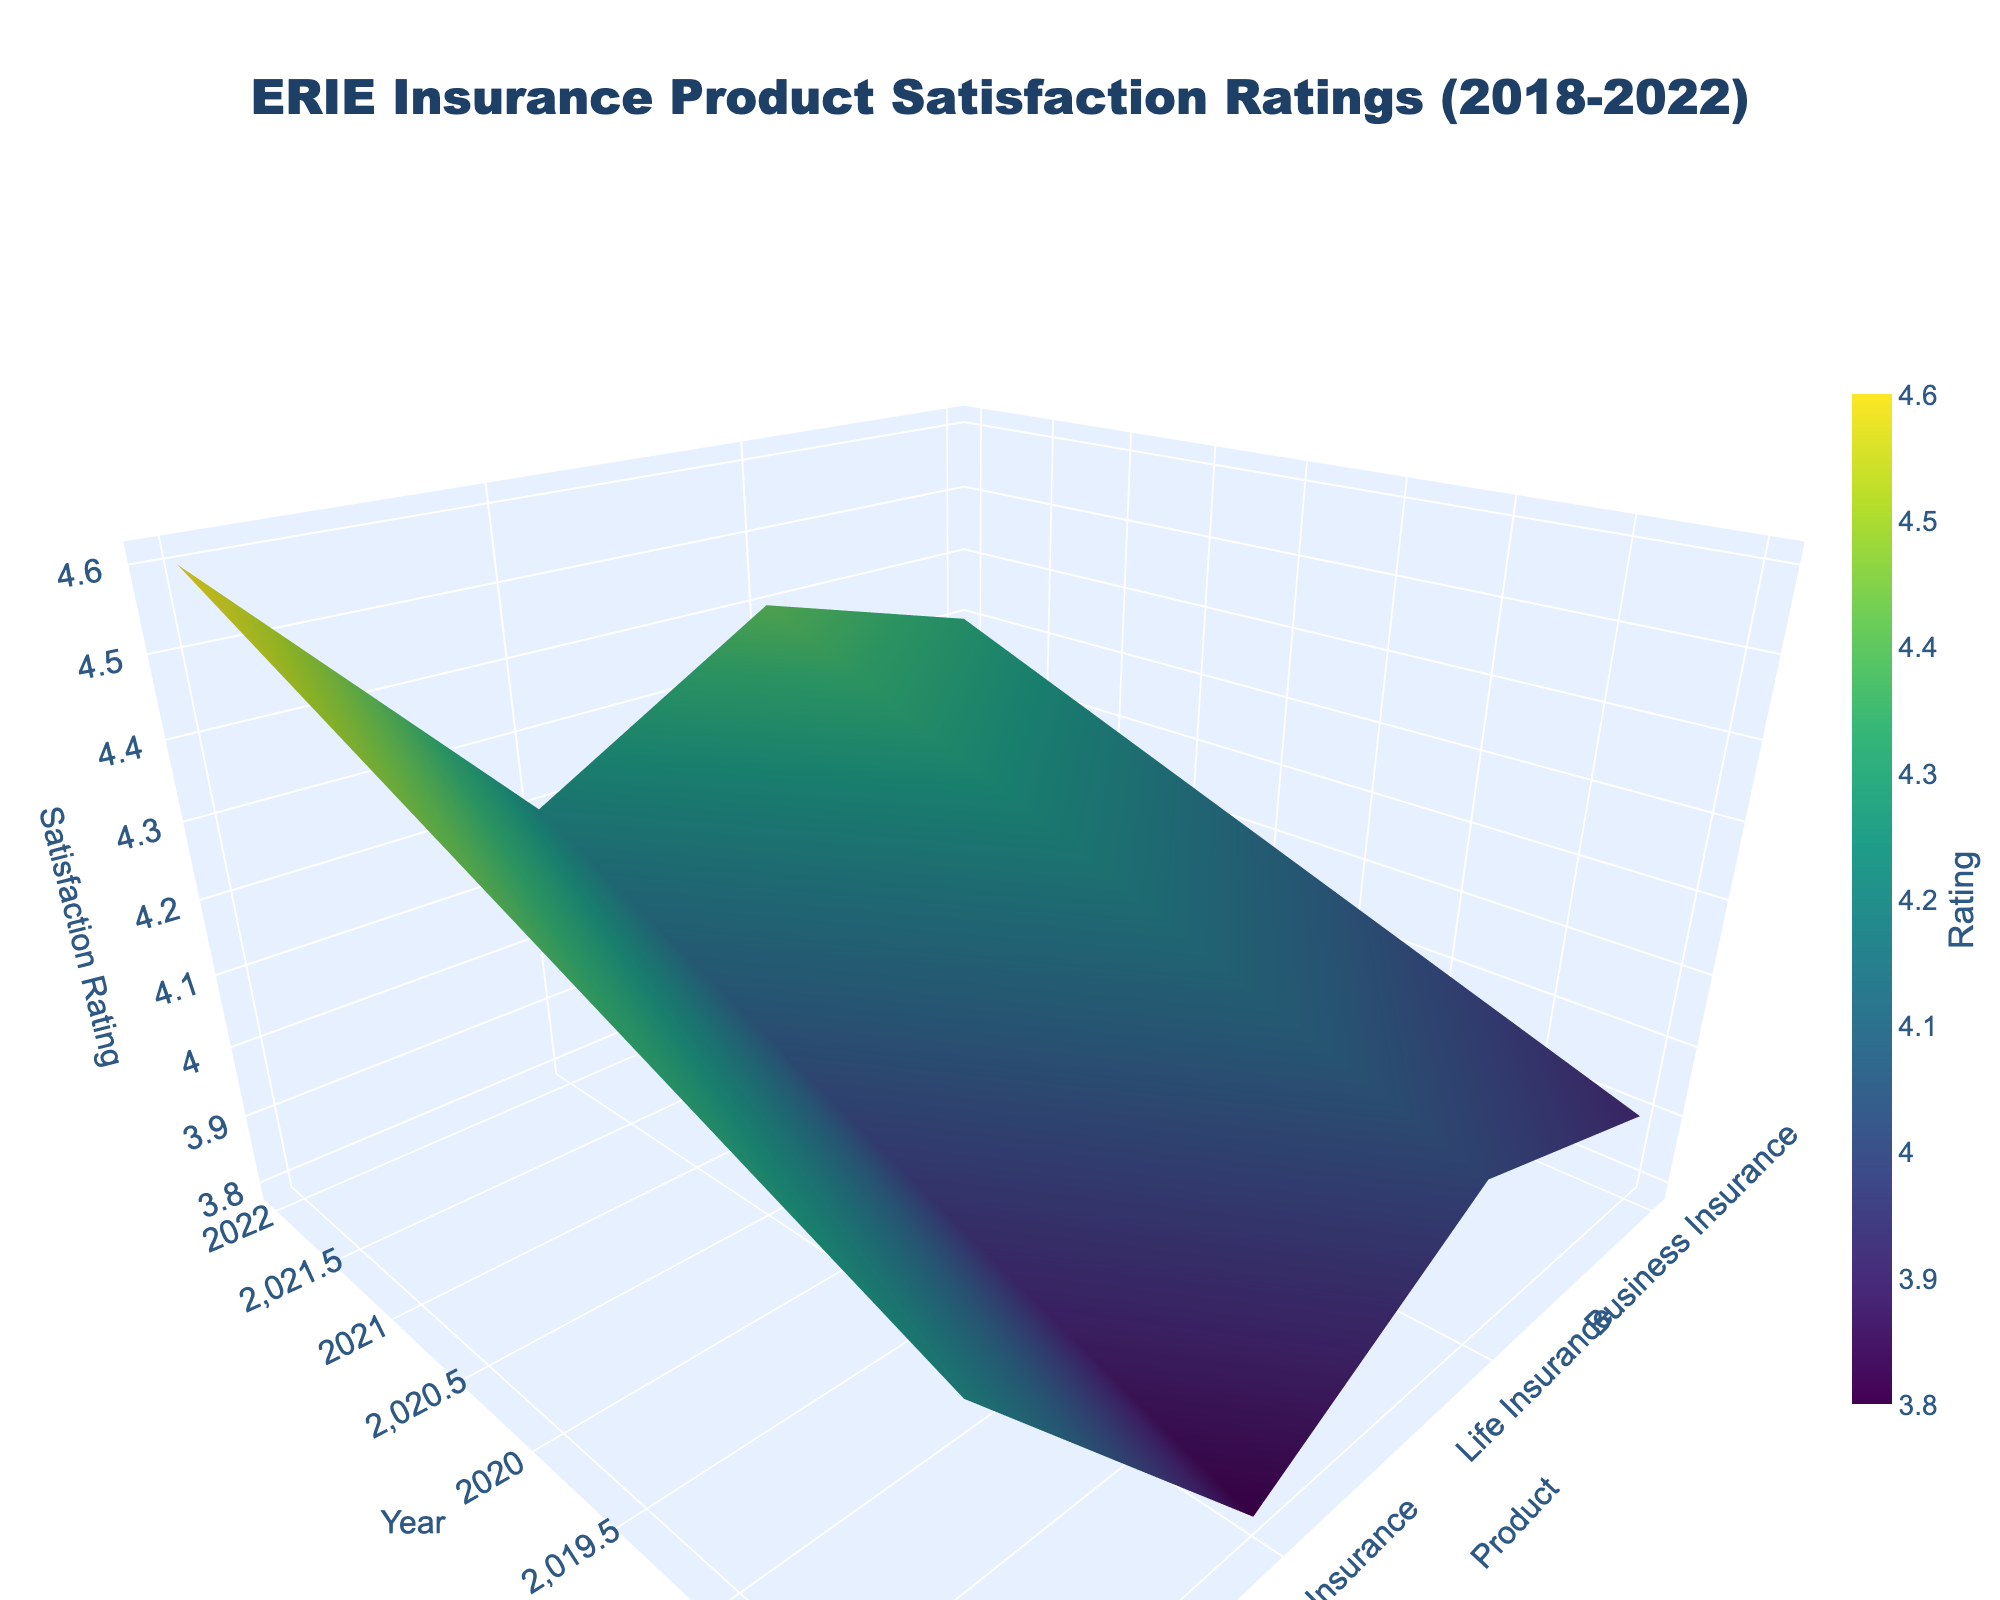What's the title of the plot? The title of the plot is displayed at the top and usually provides a succinct description of the data presented. In this case, it tells us about the content and the time range covered.
Answer: ERIE Insurance Product Satisfaction Ratings (2018-2022) Which product had the highest satisfaction rating in 2022? By examining the plot, we look at the section corresponding to 2022 on the year axis and find the highest point on the satisfaction rating axis among the different products.
Answer: Auto Insurance How did the satisfaction rating of Home Insurance change from 2018 to 2022? To find this, we observe the points on the plot corresponding to Home Insurance from the years 2018 through 2022. By looking at the y-axis corresponding to these years, we can see an upward trend in satisfaction ratings.
Answer: Increased Which insurance product had the lowest satisfaction rating in 2018? By examining the plot section corresponding to the year 2018, we look for the lowest point on the satisfaction rating axis among the different products.
Answer: Business Insurance How much did the satisfaction rating of Life Insurance increase from 2018 to 2022? By finding the points on the plot corresponding to Life Insurance in 2018 and 2022, we subtract the 2018 rating from the 2022 rating to calculate the increase.
Answer: 0.4 Compare the satisfaction ratings of Auto Insurance and Business Insurance in 2020. Locate the data points for Auto Insurance and Business Insurance in the year 2020 on the plot. Compare their heights on the satisfaction rating axis.
Answer: Auto Insurance had higher ratings What is the average satisfaction rating of Home Insurance from 2018 to 2022? To find the average, sum the satisfaction ratings of Home Insurance from 2018 through 2022 and then divide by the number of years. Calculation: (4.0 + 4.1 + 4.2 + 4.3 + 4.4) / 5.
Answer: 4.2 Which products had an increasing trend in satisfaction ratings over the years? By examining the plot, we look for products whose satisfaction ratings consistently increased from 2018 to 2022.
Answer: All products What's the color scale used in the plot to represent satisfaction ratings? The plot uses a color scale indicated in the figure legend, which visually distinguishes varying satisfaction levels.
Answer: Viridis 